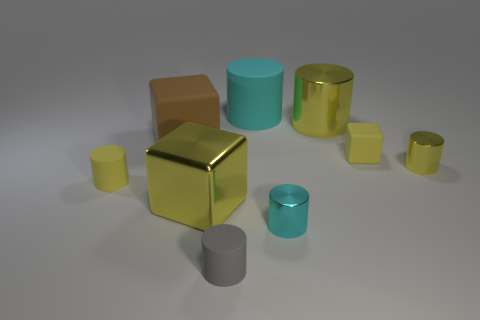How many yellow cubes must be subtracted to get 1 yellow cubes? 1 Subtract all brown spheres. How many yellow cylinders are left? 3 Subtract all tiny yellow matte cylinders. How many cylinders are left? 5 Subtract all gray cylinders. How many cylinders are left? 5 Subtract all gray cylinders. Subtract all purple balls. How many cylinders are left? 5 Add 1 brown rubber cylinders. How many objects exist? 10 Subtract all blocks. How many objects are left? 6 Subtract 0 green spheres. How many objects are left? 9 Subtract all brown matte cubes. Subtract all big cyan things. How many objects are left? 7 Add 2 big cubes. How many big cubes are left? 4 